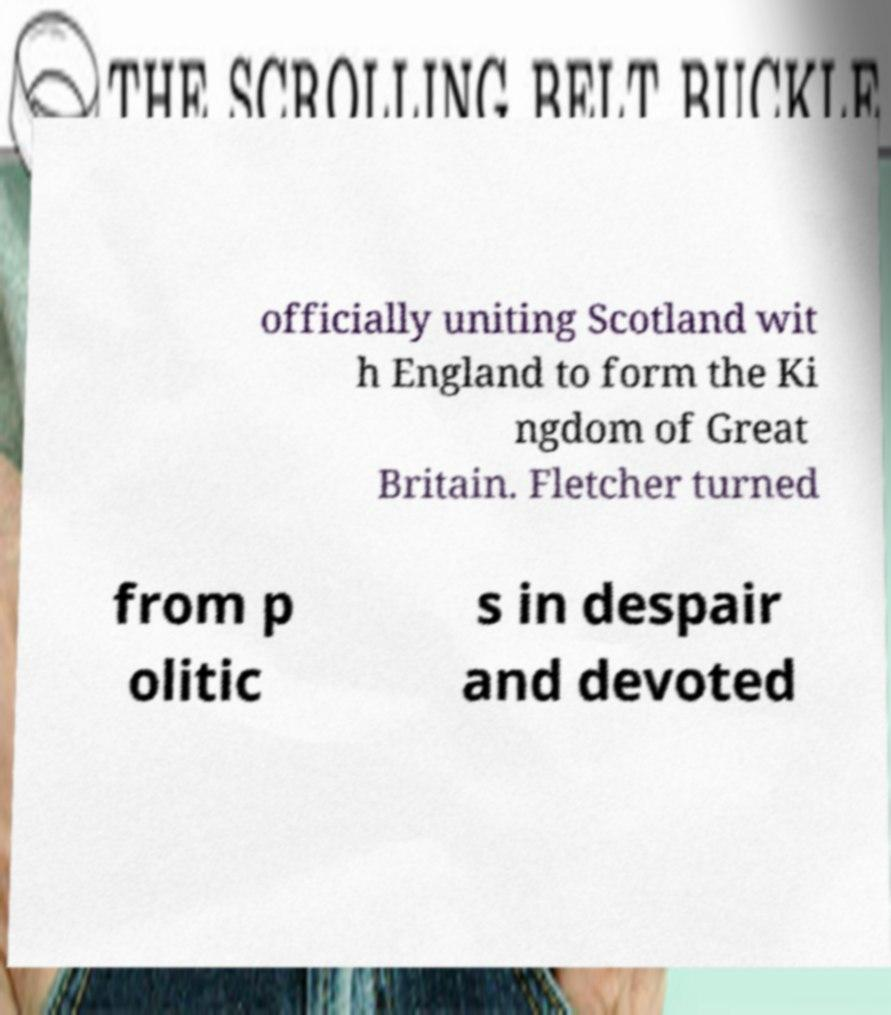I need the written content from this picture converted into text. Can you do that? officially uniting Scotland wit h England to form the Ki ngdom of Great Britain. Fletcher turned from p olitic s in despair and devoted 